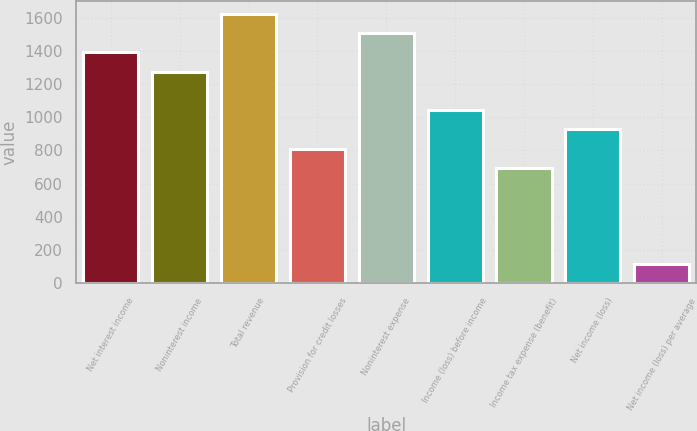Convert chart to OTSL. <chart><loc_0><loc_0><loc_500><loc_500><bar_chart><fcel>Net interest income<fcel>Noninterest income<fcel>Total revenue<fcel>Provision for credit losses<fcel>Noninterest expense<fcel>Income (loss) before income<fcel>Income tax expense (benefit)<fcel>Net income (loss)<fcel>Net income (loss) per average<nl><fcel>1389.51<fcel>1273.74<fcel>1621.05<fcel>810.66<fcel>1505.28<fcel>1042.2<fcel>694.89<fcel>926.43<fcel>116.04<nl></chart> 